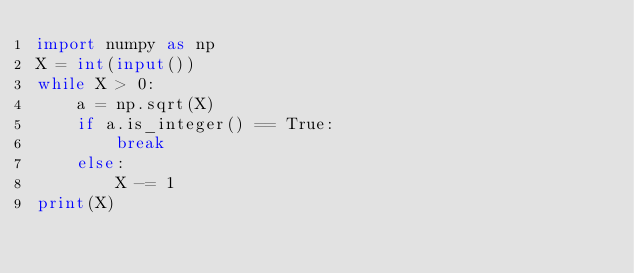<code> <loc_0><loc_0><loc_500><loc_500><_Python_>import numpy as np
X = int(input())
while X > 0:
    a = np.sqrt(X)
    if a.is_integer() == True:
        break
    else:
        X -= 1
print(X)</code> 